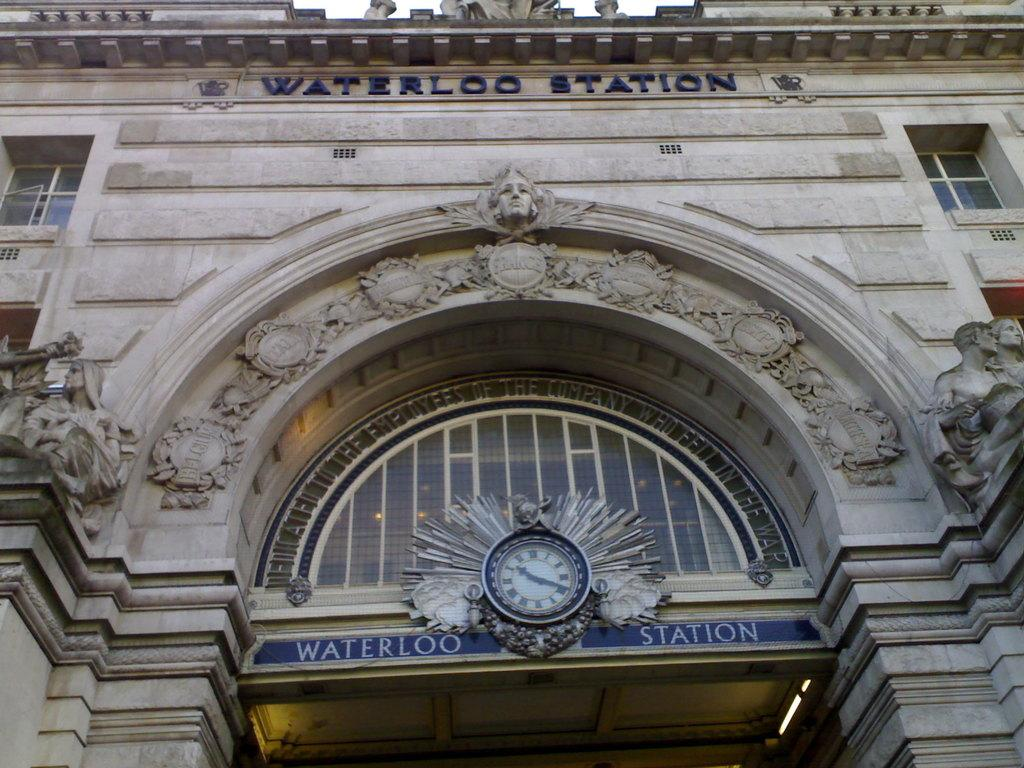<image>
Write a terse but informative summary of the picture. "WATERLOO STATION" is written in the archway by the clock. 